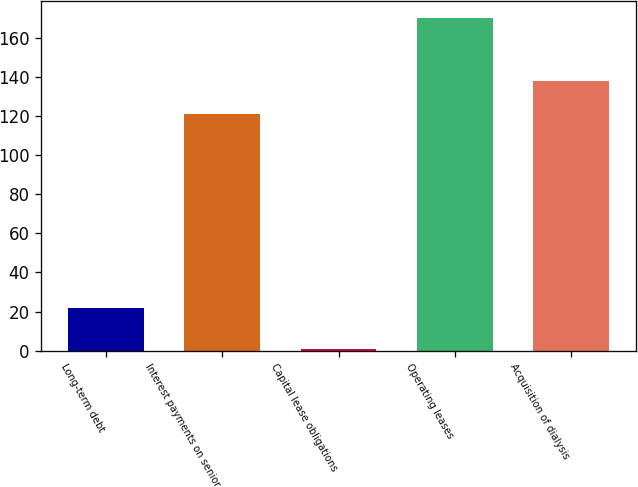Convert chart to OTSL. <chart><loc_0><loc_0><loc_500><loc_500><bar_chart><fcel>Long-term debt<fcel>Interest payments on senior<fcel>Capital lease obligations<fcel>Operating leases<fcel>Acquisition of dialysis<nl><fcel>22<fcel>121<fcel>1<fcel>170<fcel>137.9<nl></chart> 